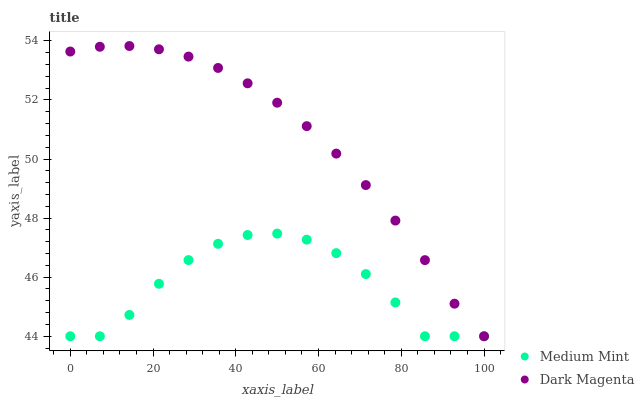Does Medium Mint have the minimum area under the curve?
Answer yes or no. Yes. Does Dark Magenta have the maximum area under the curve?
Answer yes or no. Yes. Does Dark Magenta have the minimum area under the curve?
Answer yes or no. No. Is Dark Magenta the smoothest?
Answer yes or no. Yes. Is Medium Mint the roughest?
Answer yes or no. Yes. Is Dark Magenta the roughest?
Answer yes or no. No. Does Medium Mint have the lowest value?
Answer yes or no. Yes. Does Dark Magenta have the highest value?
Answer yes or no. Yes. Does Medium Mint intersect Dark Magenta?
Answer yes or no. Yes. Is Medium Mint less than Dark Magenta?
Answer yes or no. No. Is Medium Mint greater than Dark Magenta?
Answer yes or no. No. 